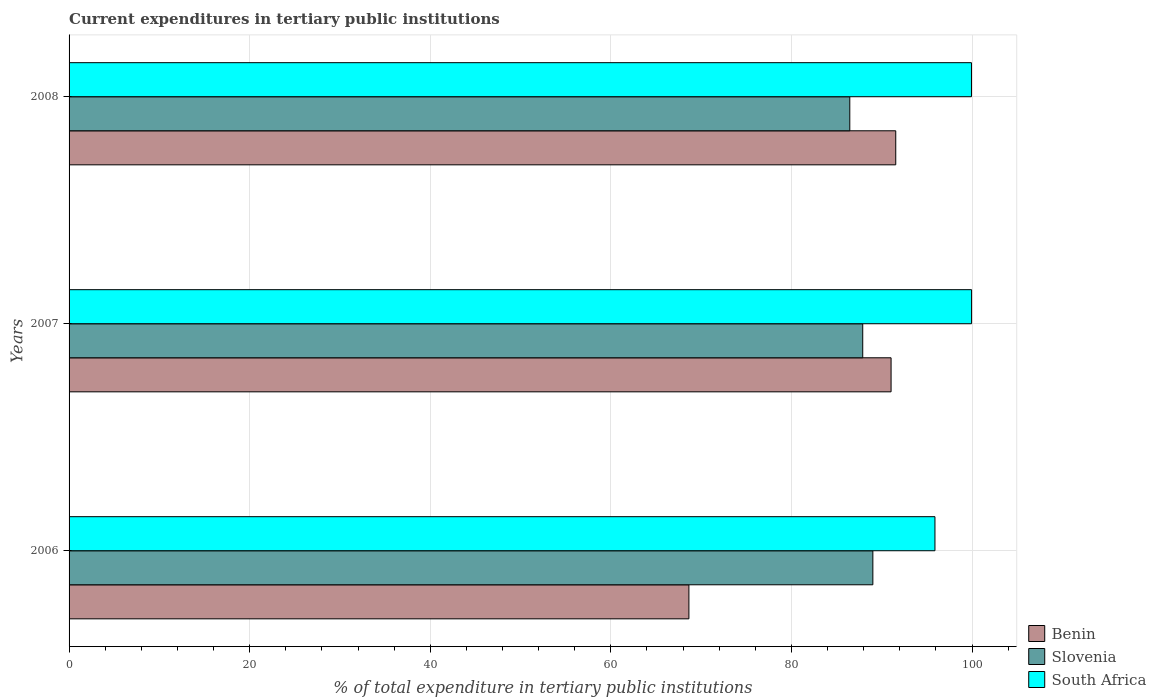How many groups of bars are there?
Your answer should be compact. 3. Are the number of bars per tick equal to the number of legend labels?
Provide a succinct answer. Yes. What is the label of the 2nd group of bars from the top?
Make the answer very short. 2007. In how many cases, is the number of bars for a given year not equal to the number of legend labels?
Offer a terse response. 0. What is the current expenditures in tertiary public institutions in Slovenia in 2008?
Provide a short and direct response. 86.47. Across all years, what is the maximum current expenditures in tertiary public institutions in South Africa?
Keep it short and to the point. 99.95. Across all years, what is the minimum current expenditures in tertiary public institutions in Slovenia?
Make the answer very short. 86.47. What is the total current expenditures in tertiary public institutions in Benin in the graph?
Your answer should be very brief. 251.24. What is the difference between the current expenditures in tertiary public institutions in Benin in 2006 and that in 2008?
Keep it short and to the point. -22.91. What is the difference between the current expenditures in tertiary public institutions in Benin in 2006 and the current expenditures in tertiary public institutions in South Africa in 2007?
Your answer should be very brief. -31.31. What is the average current expenditures in tertiary public institutions in Slovenia per year?
Keep it short and to the point. 87.8. In the year 2007, what is the difference between the current expenditures in tertiary public institutions in South Africa and current expenditures in tertiary public institutions in Benin?
Your response must be concise. 8.92. In how many years, is the current expenditures in tertiary public institutions in Benin greater than 24 %?
Keep it short and to the point. 3. What is the ratio of the current expenditures in tertiary public institutions in Slovenia in 2007 to that in 2008?
Offer a terse response. 1.02. Is the difference between the current expenditures in tertiary public institutions in South Africa in 2006 and 2007 greater than the difference between the current expenditures in tertiary public institutions in Benin in 2006 and 2007?
Offer a very short reply. Yes. What is the difference between the highest and the second highest current expenditures in tertiary public institutions in Benin?
Your answer should be compact. 0.52. What is the difference between the highest and the lowest current expenditures in tertiary public institutions in Benin?
Your answer should be very brief. 22.91. What does the 2nd bar from the top in 2007 represents?
Offer a very short reply. Slovenia. What does the 2nd bar from the bottom in 2006 represents?
Your answer should be compact. Slovenia. Is it the case that in every year, the sum of the current expenditures in tertiary public institutions in Benin and current expenditures in tertiary public institutions in South Africa is greater than the current expenditures in tertiary public institutions in Slovenia?
Provide a short and direct response. Yes. How many bars are there?
Give a very brief answer. 9. What is the difference between two consecutive major ticks on the X-axis?
Offer a terse response. 20. Are the values on the major ticks of X-axis written in scientific E-notation?
Your answer should be very brief. No. Where does the legend appear in the graph?
Offer a terse response. Bottom right. How many legend labels are there?
Offer a very short reply. 3. How are the legend labels stacked?
Provide a succinct answer. Vertical. What is the title of the graph?
Your response must be concise. Current expenditures in tertiary public institutions. What is the label or title of the X-axis?
Give a very brief answer. % of total expenditure in tertiary public institutions. What is the label or title of the Y-axis?
Your response must be concise. Years. What is the % of total expenditure in tertiary public institutions of Benin in 2006?
Offer a terse response. 68.65. What is the % of total expenditure in tertiary public institutions of Slovenia in 2006?
Ensure brevity in your answer.  89.02. What is the % of total expenditure in tertiary public institutions in South Africa in 2006?
Your answer should be compact. 95.9. What is the % of total expenditure in tertiary public institutions in Benin in 2007?
Provide a succinct answer. 91.04. What is the % of total expenditure in tertiary public institutions in Slovenia in 2007?
Offer a terse response. 87.9. What is the % of total expenditure in tertiary public institutions in South Africa in 2007?
Your answer should be compact. 99.95. What is the % of total expenditure in tertiary public institutions of Benin in 2008?
Your answer should be compact. 91.56. What is the % of total expenditure in tertiary public institutions of Slovenia in 2008?
Ensure brevity in your answer.  86.47. What is the % of total expenditure in tertiary public institutions in South Africa in 2008?
Make the answer very short. 99.94. Across all years, what is the maximum % of total expenditure in tertiary public institutions in Benin?
Your answer should be very brief. 91.56. Across all years, what is the maximum % of total expenditure in tertiary public institutions of Slovenia?
Your response must be concise. 89.02. Across all years, what is the maximum % of total expenditure in tertiary public institutions of South Africa?
Give a very brief answer. 99.95. Across all years, what is the minimum % of total expenditure in tertiary public institutions of Benin?
Your answer should be compact. 68.65. Across all years, what is the minimum % of total expenditure in tertiary public institutions in Slovenia?
Give a very brief answer. 86.47. Across all years, what is the minimum % of total expenditure in tertiary public institutions in South Africa?
Your answer should be very brief. 95.9. What is the total % of total expenditure in tertiary public institutions of Benin in the graph?
Offer a very short reply. 251.24. What is the total % of total expenditure in tertiary public institutions in Slovenia in the graph?
Offer a very short reply. 263.39. What is the total % of total expenditure in tertiary public institutions in South Africa in the graph?
Give a very brief answer. 295.79. What is the difference between the % of total expenditure in tertiary public institutions of Benin in 2006 and that in 2007?
Your answer should be very brief. -22.39. What is the difference between the % of total expenditure in tertiary public institutions of Slovenia in 2006 and that in 2007?
Ensure brevity in your answer.  1.12. What is the difference between the % of total expenditure in tertiary public institutions of South Africa in 2006 and that in 2007?
Provide a short and direct response. -4.06. What is the difference between the % of total expenditure in tertiary public institutions in Benin in 2006 and that in 2008?
Give a very brief answer. -22.91. What is the difference between the % of total expenditure in tertiary public institutions of Slovenia in 2006 and that in 2008?
Make the answer very short. 2.56. What is the difference between the % of total expenditure in tertiary public institutions in South Africa in 2006 and that in 2008?
Give a very brief answer. -4.04. What is the difference between the % of total expenditure in tertiary public institutions of Benin in 2007 and that in 2008?
Provide a short and direct response. -0.52. What is the difference between the % of total expenditure in tertiary public institutions of Slovenia in 2007 and that in 2008?
Ensure brevity in your answer.  1.43. What is the difference between the % of total expenditure in tertiary public institutions of South Africa in 2007 and that in 2008?
Offer a terse response. 0.01. What is the difference between the % of total expenditure in tertiary public institutions in Benin in 2006 and the % of total expenditure in tertiary public institutions in Slovenia in 2007?
Ensure brevity in your answer.  -19.25. What is the difference between the % of total expenditure in tertiary public institutions in Benin in 2006 and the % of total expenditure in tertiary public institutions in South Africa in 2007?
Provide a short and direct response. -31.31. What is the difference between the % of total expenditure in tertiary public institutions in Slovenia in 2006 and the % of total expenditure in tertiary public institutions in South Africa in 2007?
Keep it short and to the point. -10.93. What is the difference between the % of total expenditure in tertiary public institutions of Benin in 2006 and the % of total expenditure in tertiary public institutions of Slovenia in 2008?
Keep it short and to the point. -17.82. What is the difference between the % of total expenditure in tertiary public institutions in Benin in 2006 and the % of total expenditure in tertiary public institutions in South Africa in 2008?
Your answer should be compact. -31.29. What is the difference between the % of total expenditure in tertiary public institutions of Slovenia in 2006 and the % of total expenditure in tertiary public institutions of South Africa in 2008?
Your response must be concise. -10.92. What is the difference between the % of total expenditure in tertiary public institutions in Benin in 2007 and the % of total expenditure in tertiary public institutions in Slovenia in 2008?
Your response must be concise. 4.57. What is the difference between the % of total expenditure in tertiary public institutions in Benin in 2007 and the % of total expenditure in tertiary public institutions in South Africa in 2008?
Offer a very short reply. -8.9. What is the difference between the % of total expenditure in tertiary public institutions of Slovenia in 2007 and the % of total expenditure in tertiary public institutions of South Africa in 2008?
Your answer should be very brief. -12.04. What is the average % of total expenditure in tertiary public institutions in Benin per year?
Offer a very short reply. 83.75. What is the average % of total expenditure in tertiary public institutions of Slovenia per year?
Offer a terse response. 87.8. What is the average % of total expenditure in tertiary public institutions of South Africa per year?
Provide a succinct answer. 98.6. In the year 2006, what is the difference between the % of total expenditure in tertiary public institutions in Benin and % of total expenditure in tertiary public institutions in Slovenia?
Offer a very short reply. -20.37. In the year 2006, what is the difference between the % of total expenditure in tertiary public institutions in Benin and % of total expenditure in tertiary public institutions in South Africa?
Offer a very short reply. -27.25. In the year 2006, what is the difference between the % of total expenditure in tertiary public institutions in Slovenia and % of total expenditure in tertiary public institutions in South Africa?
Make the answer very short. -6.88. In the year 2007, what is the difference between the % of total expenditure in tertiary public institutions of Benin and % of total expenditure in tertiary public institutions of Slovenia?
Provide a short and direct response. 3.14. In the year 2007, what is the difference between the % of total expenditure in tertiary public institutions of Benin and % of total expenditure in tertiary public institutions of South Africa?
Offer a terse response. -8.92. In the year 2007, what is the difference between the % of total expenditure in tertiary public institutions of Slovenia and % of total expenditure in tertiary public institutions of South Africa?
Keep it short and to the point. -12.06. In the year 2008, what is the difference between the % of total expenditure in tertiary public institutions in Benin and % of total expenditure in tertiary public institutions in Slovenia?
Provide a short and direct response. 5.09. In the year 2008, what is the difference between the % of total expenditure in tertiary public institutions in Benin and % of total expenditure in tertiary public institutions in South Africa?
Keep it short and to the point. -8.39. In the year 2008, what is the difference between the % of total expenditure in tertiary public institutions in Slovenia and % of total expenditure in tertiary public institutions in South Africa?
Provide a short and direct response. -13.47. What is the ratio of the % of total expenditure in tertiary public institutions of Benin in 2006 to that in 2007?
Provide a short and direct response. 0.75. What is the ratio of the % of total expenditure in tertiary public institutions in Slovenia in 2006 to that in 2007?
Offer a very short reply. 1.01. What is the ratio of the % of total expenditure in tertiary public institutions in South Africa in 2006 to that in 2007?
Your response must be concise. 0.96. What is the ratio of the % of total expenditure in tertiary public institutions of Benin in 2006 to that in 2008?
Give a very brief answer. 0.75. What is the ratio of the % of total expenditure in tertiary public institutions in Slovenia in 2006 to that in 2008?
Your answer should be compact. 1.03. What is the ratio of the % of total expenditure in tertiary public institutions in South Africa in 2006 to that in 2008?
Ensure brevity in your answer.  0.96. What is the ratio of the % of total expenditure in tertiary public institutions in Slovenia in 2007 to that in 2008?
Your answer should be very brief. 1.02. What is the difference between the highest and the second highest % of total expenditure in tertiary public institutions in Benin?
Your answer should be compact. 0.52. What is the difference between the highest and the second highest % of total expenditure in tertiary public institutions of Slovenia?
Give a very brief answer. 1.12. What is the difference between the highest and the second highest % of total expenditure in tertiary public institutions in South Africa?
Your answer should be very brief. 0.01. What is the difference between the highest and the lowest % of total expenditure in tertiary public institutions of Benin?
Keep it short and to the point. 22.91. What is the difference between the highest and the lowest % of total expenditure in tertiary public institutions of Slovenia?
Provide a short and direct response. 2.56. What is the difference between the highest and the lowest % of total expenditure in tertiary public institutions in South Africa?
Your answer should be compact. 4.06. 